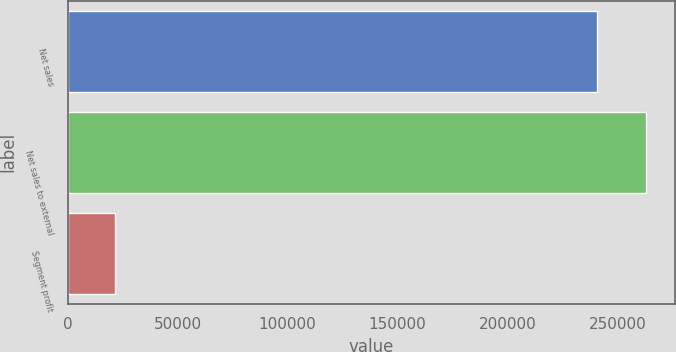Convert chart to OTSL. <chart><loc_0><loc_0><loc_500><loc_500><bar_chart><fcel>Net sales<fcel>Net sales to external<fcel>Segment profit<nl><fcel>240869<fcel>262815<fcel>21412<nl></chart> 